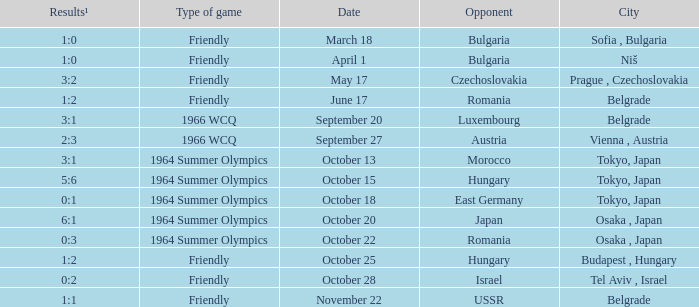What was the opponent on october 28? Israel. Give me the full table as a dictionary. {'header': ['Results¹', 'Type of game', 'Date', 'Opponent', 'City'], 'rows': [['1:0', 'Friendly', 'March 18', 'Bulgaria', 'Sofia , Bulgaria'], ['1:0', 'Friendly', 'April 1', 'Bulgaria', 'Niš'], ['3:2', 'Friendly', 'May 17', 'Czechoslovakia', 'Prague , Czechoslovakia'], ['1:2', 'Friendly', 'June 17', 'Romania', 'Belgrade'], ['3:1', '1966 WCQ', 'September 20', 'Luxembourg', 'Belgrade'], ['2:3', '1966 WCQ', 'September 27', 'Austria', 'Vienna , Austria'], ['3:1', '1964 Summer Olympics', 'October 13', 'Morocco', 'Tokyo, Japan'], ['5:6', '1964 Summer Olympics', 'October 15', 'Hungary', 'Tokyo, Japan'], ['0:1', '1964 Summer Olympics', 'October 18', 'East Germany', 'Tokyo, Japan'], ['6:1', '1964 Summer Olympics', 'October 20', 'Japan', 'Osaka , Japan'], ['0:3', '1964 Summer Olympics', 'October 22', 'Romania', 'Osaka , Japan'], ['1:2', 'Friendly', 'October 25', 'Hungary', 'Budapest , Hungary'], ['0:2', 'Friendly', 'October 28', 'Israel', 'Tel Aviv , Israel'], ['1:1', 'Friendly', 'November 22', 'USSR', 'Belgrade']]} 